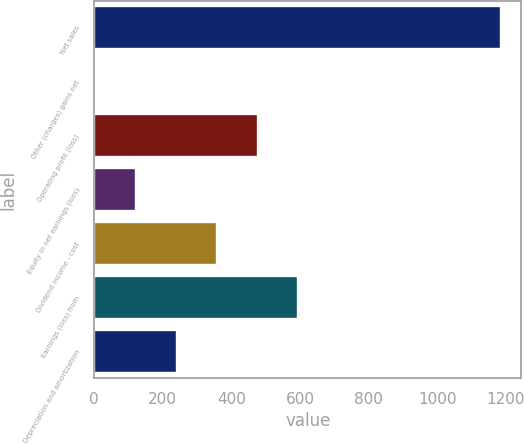Convert chart. <chart><loc_0><loc_0><loc_500><loc_500><bar_chart><fcel>Net sales<fcel>Other (charges) gains net<fcel>Operating profit (loss)<fcel>Equity in net earnings (loss)<fcel>Dividend income - cost<fcel>Earnings (loss) from<fcel>Depreciation and amortization<nl><fcel>1186<fcel>4<fcel>476.8<fcel>122.2<fcel>358.6<fcel>595<fcel>240.4<nl></chart> 